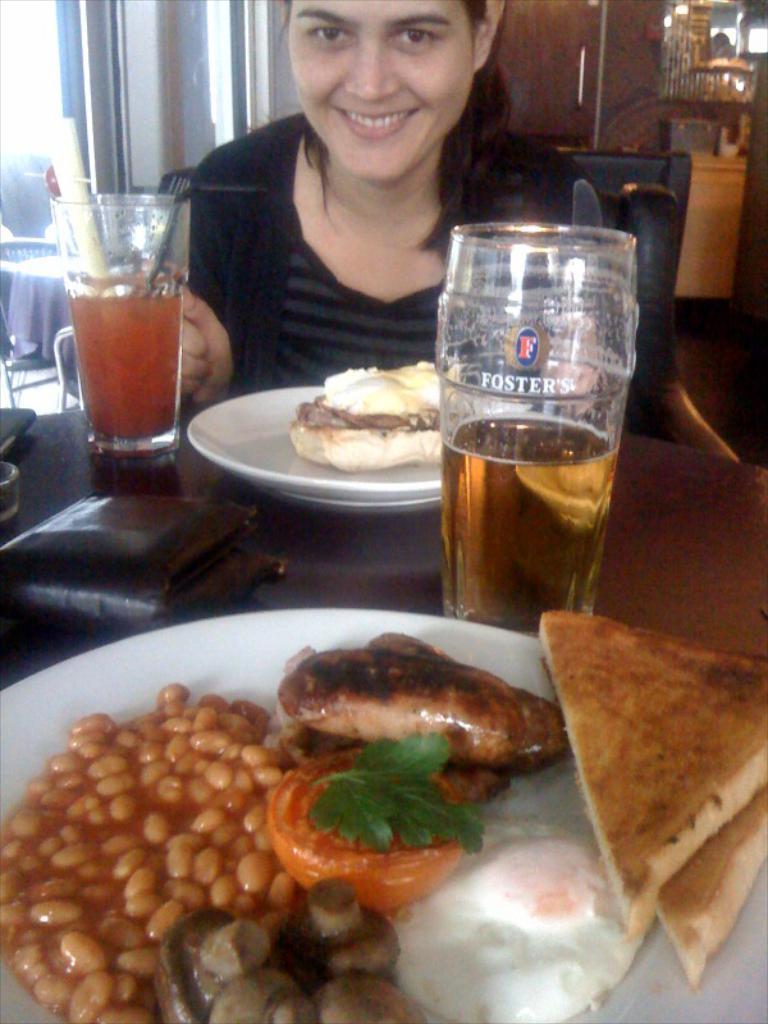Describe this image in one or two sentences. In this picture there is a woman wearing black dress is sitting and there is a table in front of her which has few eatables,glass of drink and some other objects on it and there is a door in the background. 